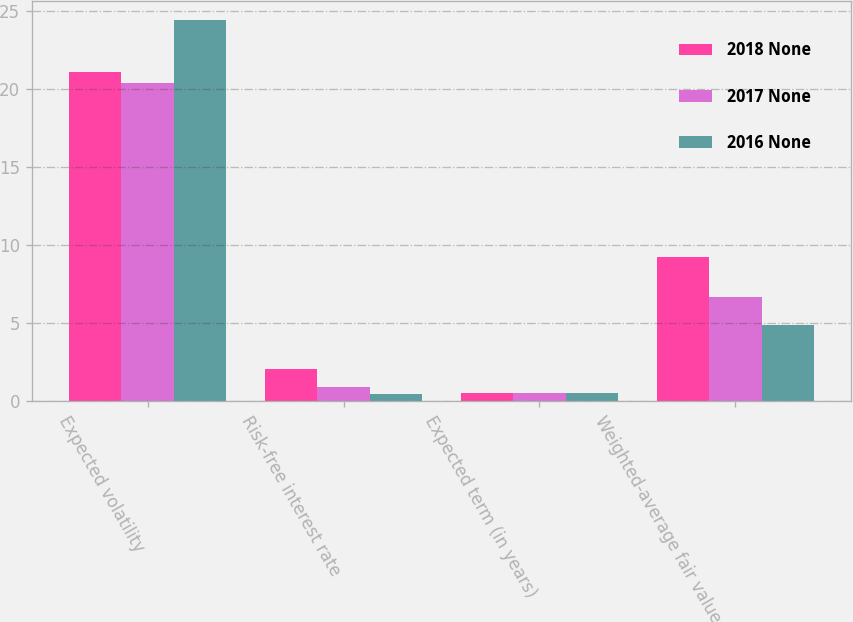Convert chart to OTSL. <chart><loc_0><loc_0><loc_500><loc_500><stacked_bar_chart><ecel><fcel>Expected volatility<fcel>Risk-free interest rate<fcel>Expected term (in years)<fcel>Weighted-average fair value of<nl><fcel>2018 None<fcel>21.1<fcel>2.05<fcel>0.5<fcel>9.24<nl><fcel>2017 None<fcel>20.4<fcel>0.92<fcel>0.5<fcel>6.64<nl><fcel>2016 None<fcel>24.4<fcel>0.43<fcel>0.5<fcel>4.85<nl></chart> 